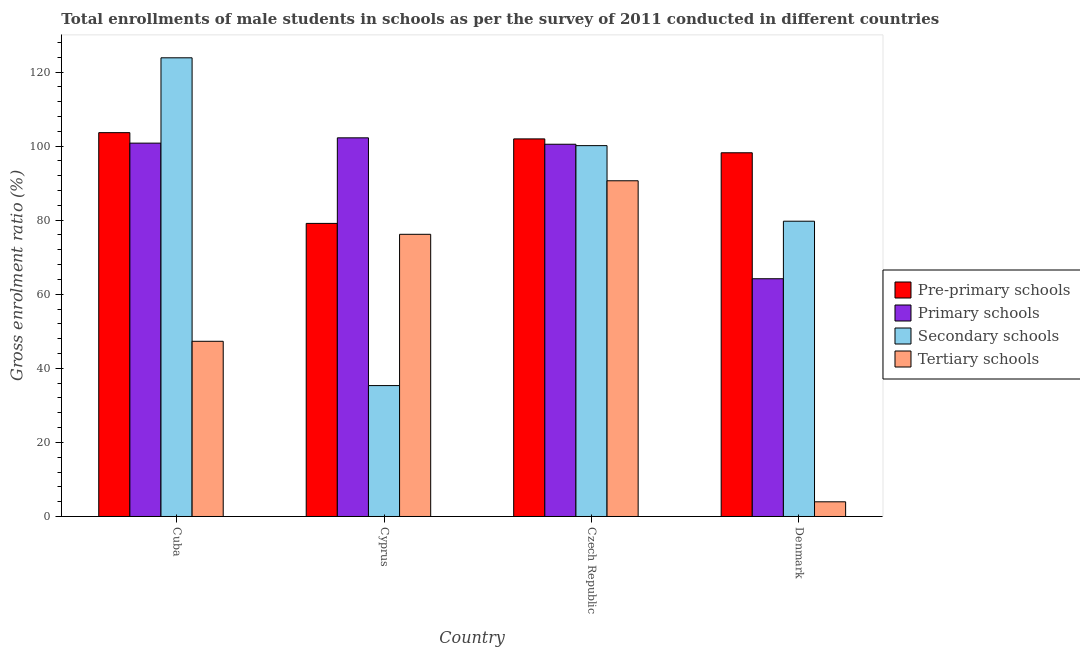How many different coloured bars are there?
Your answer should be very brief. 4. What is the label of the 2nd group of bars from the left?
Offer a very short reply. Cyprus. What is the gross enrolment ratio(male) in tertiary schools in Cuba?
Offer a terse response. 47.3. Across all countries, what is the maximum gross enrolment ratio(male) in pre-primary schools?
Keep it short and to the point. 103.63. Across all countries, what is the minimum gross enrolment ratio(male) in primary schools?
Ensure brevity in your answer.  64.19. In which country was the gross enrolment ratio(male) in primary schools maximum?
Give a very brief answer. Cyprus. In which country was the gross enrolment ratio(male) in primary schools minimum?
Keep it short and to the point. Denmark. What is the total gross enrolment ratio(male) in primary schools in the graph?
Offer a very short reply. 367.71. What is the difference between the gross enrolment ratio(male) in secondary schools in Cuba and that in Czech Republic?
Provide a succinct answer. 23.71. What is the difference between the gross enrolment ratio(male) in primary schools in Denmark and the gross enrolment ratio(male) in pre-primary schools in Czech Republic?
Your answer should be compact. -37.76. What is the average gross enrolment ratio(male) in primary schools per country?
Your answer should be compact. 91.93. What is the difference between the gross enrolment ratio(male) in pre-primary schools and gross enrolment ratio(male) in secondary schools in Cyprus?
Give a very brief answer. 43.78. In how many countries, is the gross enrolment ratio(male) in secondary schools greater than 100 %?
Your answer should be compact. 2. What is the ratio of the gross enrolment ratio(male) in pre-primary schools in Cyprus to that in Czech Republic?
Your response must be concise. 0.78. Is the gross enrolment ratio(male) in pre-primary schools in Cuba less than that in Cyprus?
Make the answer very short. No. Is the difference between the gross enrolment ratio(male) in primary schools in Cyprus and Denmark greater than the difference between the gross enrolment ratio(male) in secondary schools in Cyprus and Denmark?
Ensure brevity in your answer.  Yes. What is the difference between the highest and the second highest gross enrolment ratio(male) in pre-primary schools?
Offer a terse response. 1.69. What is the difference between the highest and the lowest gross enrolment ratio(male) in pre-primary schools?
Offer a terse response. 24.5. In how many countries, is the gross enrolment ratio(male) in pre-primary schools greater than the average gross enrolment ratio(male) in pre-primary schools taken over all countries?
Offer a very short reply. 3. Is it the case that in every country, the sum of the gross enrolment ratio(male) in pre-primary schools and gross enrolment ratio(male) in tertiary schools is greater than the sum of gross enrolment ratio(male) in secondary schools and gross enrolment ratio(male) in primary schools?
Your answer should be very brief. No. What does the 2nd bar from the left in Denmark represents?
Offer a very short reply. Primary schools. What does the 2nd bar from the right in Denmark represents?
Make the answer very short. Secondary schools. How many bars are there?
Your answer should be very brief. 16. Are all the bars in the graph horizontal?
Your answer should be very brief. No. How many countries are there in the graph?
Provide a short and direct response. 4. Does the graph contain any zero values?
Your answer should be very brief. No. How are the legend labels stacked?
Your answer should be very brief. Vertical. What is the title of the graph?
Give a very brief answer. Total enrollments of male students in schools as per the survey of 2011 conducted in different countries. Does "PFC gas" appear as one of the legend labels in the graph?
Offer a terse response. No. What is the label or title of the X-axis?
Provide a short and direct response. Country. What is the label or title of the Y-axis?
Keep it short and to the point. Gross enrolment ratio (%). What is the Gross enrolment ratio (%) in Pre-primary schools in Cuba?
Your answer should be very brief. 103.63. What is the Gross enrolment ratio (%) in Primary schools in Cuba?
Your answer should be very brief. 100.79. What is the Gross enrolment ratio (%) in Secondary schools in Cuba?
Ensure brevity in your answer.  123.83. What is the Gross enrolment ratio (%) of Tertiary schools in Cuba?
Offer a very short reply. 47.3. What is the Gross enrolment ratio (%) of Pre-primary schools in Cyprus?
Offer a very short reply. 79.13. What is the Gross enrolment ratio (%) in Primary schools in Cyprus?
Offer a very short reply. 102.23. What is the Gross enrolment ratio (%) in Secondary schools in Cyprus?
Make the answer very short. 35.34. What is the Gross enrolment ratio (%) in Tertiary schools in Cyprus?
Give a very brief answer. 76.18. What is the Gross enrolment ratio (%) in Pre-primary schools in Czech Republic?
Make the answer very short. 101.94. What is the Gross enrolment ratio (%) in Primary schools in Czech Republic?
Your answer should be very brief. 100.5. What is the Gross enrolment ratio (%) of Secondary schools in Czech Republic?
Your answer should be compact. 100.12. What is the Gross enrolment ratio (%) of Tertiary schools in Czech Republic?
Provide a short and direct response. 90.63. What is the Gross enrolment ratio (%) of Pre-primary schools in Denmark?
Keep it short and to the point. 98.19. What is the Gross enrolment ratio (%) of Primary schools in Denmark?
Your answer should be compact. 64.19. What is the Gross enrolment ratio (%) in Secondary schools in Denmark?
Give a very brief answer. 79.72. What is the Gross enrolment ratio (%) of Tertiary schools in Denmark?
Keep it short and to the point. 3.96. Across all countries, what is the maximum Gross enrolment ratio (%) in Pre-primary schools?
Your answer should be very brief. 103.63. Across all countries, what is the maximum Gross enrolment ratio (%) in Primary schools?
Offer a terse response. 102.23. Across all countries, what is the maximum Gross enrolment ratio (%) in Secondary schools?
Your response must be concise. 123.83. Across all countries, what is the maximum Gross enrolment ratio (%) of Tertiary schools?
Offer a very short reply. 90.63. Across all countries, what is the minimum Gross enrolment ratio (%) in Pre-primary schools?
Keep it short and to the point. 79.13. Across all countries, what is the minimum Gross enrolment ratio (%) in Primary schools?
Provide a short and direct response. 64.19. Across all countries, what is the minimum Gross enrolment ratio (%) in Secondary schools?
Ensure brevity in your answer.  35.34. Across all countries, what is the minimum Gross enrolment ratio (%) in Tertiary schools?
Ensure brevity in your answer.  3.96. What is the total Gross enrolment ratio (%) of Pre-primary schools in the graph?
Offer a very short reply. 382.89. What is the total Gross enrolment ratio (%) of Primary schools in the graph?
Make the answer very short. 367.71. What is the total Gross enrolment ratio (%) of Secondary schools in the graph?
Keep it short and to the point. 339.01. What is the total Gross enrolment ratio (%) of Tertiary schools in the graph?
Provide a short and direct response. 218.08. What is the difference between the Gross enrolment ratio (%) in Pre-primary schools in Cuba and that in Cyprus?
Make the answer very short. 24.5. What is the difference between the Gross enrolment ratio (%) of Primary schools in Cuba and that in Cyprus?
Make the answer very short. -1.43. What is the difference between the Gross enrolment ratio (%) in Secondary schools in Cuba and that in Cyprus?
Offer a terse response. 88.49. What is the difference between the Gross enrolment ratio (%) of Tertiary schools in Cuba and that in Cyprus?
Provide a succinct answer. -28.88. What is the difference between the Gross enrolment ratio (%) of Pre-primary schools in Cuba and that in Czech Republic?
Your answer should be very brief. 1.69. What is the difference between the Gross enrolment ratio (%) of Primary schools in Cuba and that in Czech Republic?
Provide a succinct answer. 0.3. What is the difference between the Gross enrolment ratio (%) of Secondary schools in Cuba and that in Czech Republic?
Give a very brief answer. 23.71. What is the difference between the Gross enrolment ratio (%) in Tertiary schools in Cuba and that in Czech Republic?
Your response must be concise. -43.33. What is the difference between the Gross enrolment ratio (%) of Pre-primary schools in Cuba and that in Denmark?
Ensure brevity in your answer.  5.43. What is the difference between the Gross enrolment ratio (%) of Primary schools in Cuba and that in Denmark?
Provide a succinct answer. 36.61. What is the difference between the Gross enrolment ratio (%) of Secondary schools in Cuba and that in Denmark?
Offer a very short reply. 44.12. What is the difference between the Gross enrolment ratio (%) in Tertiary schools in Cuba and that in Denmark?
Offer a very short reply. 43.34. What is the difference between the Gross enrolment ratio (%) in Pre-primary schools in Cyprus and that in Czech Republic?
Offer a very short reply. -22.82. What is the difference between the Gross enrolment ratio (%) of Primary schools in Cyprus and that in Czech Republic?
Your answer should be compact. 1.73. What is the difference between the Gross enrolment ratio (%) of Secondary schools in Cyprus and that in Czech Republic?
Ensure brevity in your answer.  -64.78. What is the difference between the Gross enrolment ratio (%) of Tertiary schools in Cyprus and that in Czech Republic?
Offer a terse response. -14.45. What is the difference between the Gross enrolment ratio (%) in Pre-primary schools in Cyprus and that in Denmark?
Offer a very short reply. -19.07. What is the difference between the Gross enrolment ratio (%) in Primary schools in Cyprus and that in Denmark?
Make the answer very short. 38.04. What is the difference between the Gross enrolment ratio (%) in Secondary schools in Cyprus and that in Denmark?
Make the answer very short. -44.38. What is the difference between the Gross enrolment ratio (%) of Tertiary schools in Cyprus and that in Denmark?
Provide a succinct answer. 72.22. What is the difference between the Gross enrolment ratio (%) in Pre-primary schools in Czech Republic and that in Denmark?
Keep it short and to the point. 3.75. What is the difference between the Gross enrolment ratio (%) in Primary schools in Czech Republic and that in Denmark?
Your answer should be compact. 36.31. What is the difference between the Gross enrolment ratio (%) in Secondary schools in Czech Republic and that in Denmark?
Your response must be concise. 20.41. What is the difference between the Gross enrolment ratio (%) of Tertiary schools in Czech Republic and that in Denmark?
Ensure brevity in your answer.  86.67. What is the difference between the Gross enrolment ratio (%) of Pre-primary schools in Cuba and the Gross enrolment ratio (%) of Primary schools in Cyprus?
Offer a terse response. 1.4. What is the difference between the Gross enrolment ratio (%) in Pre-primary schools in Cuba and the Gross enrolment ratio (%) in Secondary schools in Cyprus?
Provide a short and direct response. 68.29. What is the difference between the Gross enrolment ratio (%) in Pre-primary schools in Cuba and the Gross enrolment ratio (%) in Tertiary schools in Cyprus?
Your response must be concise. 27.45. What is the difference between the Gross enrolment ratio (%) in Primary schools in Cuba and the Gross enrolment ratio (%) in Secondary schools in Cyprus?
Your answer should be compact. 65.45. What is the difference between the Gross enrolment ratio (%) of Primary schools in Cuba and the Gross enrolment ratio (%) of Tertiary schools in Cyprus?
Offer a very short reply. 24.61. What is the difference between the Gross enrolment ratio (%) of Secondary schools in Cuba and the Gross enrolment ratio (%) of Tertiary schools in Cyprus?
Make the answer very short. 47.65. What is the difference between the Gross enrolment ratio (%) in Pre-primary schools in Cuba and the Gross enrolment ratio (%) in Primary schools in Czech Republic?
Offer a terse response. 3.13. What is the difference between the Gross enrolment ratio (%) of Pre-primary schools in Cuba and the Gross enrolment ratio (%) of Secondary schools in Czech Republic?
Your response must be concise. 3.51. What is the difference between the Gross enrolment ratio (%) in Pre-primary schools in Cuba and the Gross enrolment ratio (%) in Tertiary schools in Czech Republic?
Make the answer very short. 12.99. What is the difference between the Gross enrolment ratio (%) in Primary schools in Cuba and the Gross enrolment ratio (%) in Secondary schools in Czech Republic?
Your answer should be compact. 0.67. What is the difference between the Gross enrolment ratio (%) in Primary schools in Cuba and the Gross enrolment ratio (%) in Tertiary schools in Czech Republic?
Give a very brief answer. 10.16. What is the difference between the Gross enrolment ratio (%) of Secondary schools in Cuba and the Gross enrolment ratio (%) of Tertiary schools in Czech Republic?
Your answer should be compact. 33.2. What is the difference between the Gross enrolment ratio (%) in Pre-primary schools in Cuba and the Gross enrolment ratio (%) in Primary schools in Denmark?
Your response must be concise. 39.44. What is the difference between the Gross enrolment ratio (%) of Pre-primary schools in Cuba and the Gross enrolment ratio (%) of Secondary schools in Denmark?
Provide a succinct answer. 23.91. What is the difference between the Gross enrolment ratio (%) of Pre-primary schools in Cuba and the Gross enrolment ratio (%) of Tertiary schools in Denmark?
Your answer should be very brief. 99.67. What is the difference between the Gross enrolment ratio (%) of Primary schools in Cuba and the Gross enrolment ratio (%) of Secondary schools in Denmark?
Make the answer very short. 21.08. What is the difference between the Gross enrolment ratio (%) in Primary schools in Cuba and the Gross enrolment ratio (%) in Tertiary schools in Denmark?
Your answer should be compact. 96.83. What is the difference between the Gross enrolment ratio (%) in Secondary schools in Cuba and the Gross enrolment ratio (%) in Tertiary schools in Denmark?
Offer a terse response. 119.87. What is the difference between the Gross enrolment ratio (%) in Pre-primary schools in Cyprus and the Gross enrolment ratio (%) in Primary schools in Czech Republic?
Your response must be concise. -21.37. What is the difference between the Gross enrolment ratio (%) in Pre-primary schools in Cyprus and the Gross enrolment ratio (%) in Secondary schools in Czech Republic?
Provide a short and direct response. -21. What is the difference between the Gross enrolment ratio (%) in Pre-primary schools in Cyprus and the Gross enrolment ratio (%) in Tertiary schools in Czech Republic?
Your response must be concise. -11.51. What is the difference between the Gross enrolment ratio (%) in Primary schools in Cyprus and the Gross enrolment ratio (%) in Secondary schools in Czech Republic?
Your response must be concise. 2.11. What is the difference between the Gross enrolment ratio (%) of Primary schools in Cyprus and the Gross enrolment ratio (%) of Tertiary schools in Czech Republic?
Give a very brief answer. 11.59. What is the difference between the Gross enrolment ratio (%) of Secondary schools in Cyprus and the Gross enrolment ratio (%) of Tertiary schools in Czech Republic?
Ensure brevity in your answer.  -55.29. What is the difference between the Gross enrolment ratio (%) in Pre-primary schools in Cyprus and the Gross enrolment ratio (%) in Primary schools in Denmark?
Keep it short and to the point. 14.94. What is the difference between the Gross enrolment ratio (%) of Pre-primary schools in Cyprus and the Gross enrolment ratio (%) of Secondary schools in Denmark?
Offer a terse response. -0.59. What is the difference between the Gross enrolment ratio (%) in Pre-primary schools in Cyprus and the Gross enrolment ratio (%) in Tertiary schools in Denmark?
Offer a terse response. 75.16. What is the difference between the Gross enrolment ratio (%) in Primary schools in Cyprus and the Gross enrolment ratio (%) in Secondary schools in Denmark?
Provide a succinct answer. 22.51. What is the difference between the Gross enrolment ratio (%) of Primary schools in Cyprus and the Gross enrolment ratio (%) of Tertiary schools in Denmark?
Provide a succinct answer. 98.27. What is the difference between the Gross enrolment ratio (%) of Secondary schools in Cyprus and the Gross enrolment ratio (%) of Tertiary schools in Denmark?
Your answer should be compact. 31.38. What is the difference between the Gross enrolment ratio (%) in Pre-primary schools in Czech Republic and the Gross enrolment ratio (%) in Primary schools in Denmark?
Offer a very short reply. 37.76. What is the difference between the Gross enrolment ratio (%) in Pre-primary schools in Czech Republic and the Gross enrolment ratio (%) in Secondary schools in Denmark?
Offer a very short reply. 22.23. What is the difference between the Gross enrolment ratio (%) of Pre-primary schools in Czech Republic and the Gross enrolment ratio (%) of Tertiary schools in Denmark?
Keep it short and to the point. 97.98. What is the difference between the Gross enrolment ratio (%) of Primary schools in Czech Republic and the Gross enrolment ratio (%) of Secondary schools in Denmark?
Keep it short and to the point. 20.78. What is the difference between the Gross enrolment ratio (%) of Primary schools in Czech Republic and the Gross enrolment ratio (%) of Tertiary schools in Denmark?
Offer a very short reply. 96.53. What is the difference between the Gross enrolment ratio (%) of Secondary schools in Czech Republic and the Gross enrolment ratio (%) of Tertiary schools in Denmark?
Provide a succinct answer. 96.16. What is the average Gross enrolment ratio (%) in Pre-primary schools per country?
Provide a short and direct response. 95.72. What is the average Gross enrolment ratio (%) in Primary schools per country?
Give a very brief answer. 91.93. What is the average Gross enrolment ratio (%) in Secondary schools per country?
Your response must be concise. 84.75. What is the average Gross enrolment ratio (%) of Tertiary schools per country?
Offer a terse response. 54.52. What is the difference between the Gross enrolment ratio (%) in Pre-primary schools and Gross enrolment ratio (%) in Primary schools in Cuba?
Keep it short and to the point. 2.83. What is the difference between the Gross enrolment ratio (%) in Pre-primary schools and Gross enrolment ratio (%) in Secondary schools in Cuba?
Keep it short and to the point. -20.2. What is the difference between the Gross enrolment ratio (%) of Pre-primary schools and Gross enrolment ratio (%) of Tertiary schools in Cuba?
Provide a succinct answer. 56.33. What is the difference between the Gross enrolment ratio (%) in Primary schools and Gross enrolment ratio (%) in Secondary schools in Cuba?
Your answer should be compact. -23.04. What is the difference between the Gross enrolment ratio (%) of Primary schools and Gross enrolment ratio (%) of Tertiary schools in Cuba?
Give a very brief answer. 53.5. What is the difference between the Gross enrolment ratio (%) of Secondary schools and Gross enrolment ratio (%) of Tertiary schools in Cuba?
Provide a short and direct response. 76.53. What is the difference between the Gross enrolment ratio (%) in Pre-primary schools and Gross enrolment ratio (%) in Primary schools in Cyprus?
Your answer should be compact. -23.1. What is the difference between the Gross enrolment ratio (%) of Pre-primary schools and Gross enrolment ratio (%) of Secondary schools in Cyprus?
Provide a short and direct response. 43.78. What is the difference between the Gross enrolment ratio (%) of Pre-primary schools and Gross enrolment ratio (%) of Tertiary schools in Cyprus?
Ensure brevity in your answer.  2.94. What is the difference between the Gross enrolment ratio (%) of Primary schools and Gross enrolment ratio (%) of Secondary schools in Cyprus?
Keep it short and to the point. 66.89. What is the difference between the Gross enrolment ratio (%) of Primary schools and Gross enrolment ratio (%) of Tertiary schools in Cyprus?
Keep it short and to the point. 26.05. What is the difference between the Gross enrolment ratio (%) of Secondary schools and Gross enrolment ratio (%) of Tertiary schools in Cyprus?
Provide a short and direct response. -40.84. What is the difference between the Gross enrolment ratio (%) of Pre-primary schools and Gross enrolment ratio (%) of Primary schools in Czech Republic?
Your answer should be very brief. 1.44. What is the difference between the Gross enrolment ratio (%) in Pre-primary schools and Gross enrolment ratio (%) in Secondary schools in Czech Republic?
Your response must be concise. 1.82. What is the difference between the Gross enrolment ratio (%) in Pre-primary schools and Gross enrolment ratio (%) in Tertiary schools in Czech Republic?
Give a very brief answer. 11.31. What is the difference between the Gross enrolment ratio (%) of Primary schools and Gross enrolment ratio (%) of Secondary schools in Czech Republic?
Offer a very short reply. 0.38. What is the difference between the Gross enrolment ratio (%) in Primary schools and Gross enrolment ratio (%) in Tertiary schools in Czech Republic?
Keep it short and to the point. 9.86. What is the difference between the Gross enrolment ratio (%) of Secondary schools and Gross enrolment ratio (%) of Tertiary schools in Czech Republic?
Give a very brief answer. 9.49. What is the difference between the Gross enrolment ratio (%) of Pre-primary schools and Gross enrolment ratio (%) of Primary schools in Denmark?
Ensure brevity in your answer.  34.01. What is the difference between the Gross enrolment ratio (%) in Pre-primary schools and Gross enrolment ratio (%) in Secondary schools in Denmark?
Your answer should be compact. 18.48. What is the difference between the Gross enrolment ratio (%) of Pre-primary schools and Gross enrolment ratio (%) of Tertiary schools in Denmark?
Offer a terse response. 94.23. What is the difference between the Gross enrolment ratio (%) of Primary schools and Gross enrolment ratio (%) of Secondary schools in Denmark?
Offer a terse response. -15.53. What is the difference between the Gross enrolment ratio (%) in Primary schools and Gross enrolment ratio (%) in Tertiary schools in Denmark?
Offer a very short reply. 60.22. What is the difference between the Gross enrolment ratio (%) of Secondary schools and Gross enrolment ratio (%) of Tertiary schools in Denmark?
Provide a succinct answer. 75.75. What is the ratio of the Gross enrolment ratio (%) of Pre-primary schools in Cuba to that in Cyprus?
Your answer should be compact. 1.31. What is the ratio of the Gross enrolment ratio (%) of Primary schools in Cuba to that in Cyprus?
Provide a succinct answer. 0.99. What is the ratio of the Gross enrolment ratio (%) of Secondary schools in Cuba to that in Cyprus?
Offer a terse response. 3.5. What is the ratio of the Gross enrolment ratio (%) of Tertiary schools in Cuba to that in Cyprus?
Make the answer very short. 0.62. What is the ratio of the Gross enrolment ratio (%) of Pre-primary schools in Cuba to that in Czech Republic?
Provide a succinct answer. 1.02. What is the ratio of the Gross enrolment ratio (%) of Secondary schools in Cuba to that in Czech Republic?
Make the answer very short. 1.24. What is the ratio of the Gross enrolment ratio (%) in Tertiary schools in Cuba to that in Czech Republic?
Give a very brief answer. 0.52. What is the ratio of the Gross enrolment ratio (%) in Pre-primary schools in Cuba to that in Denmark?
Provide a succinct answer. 1.06. What is the ratio of the Gross enrolment ratio (%) in Primary schools in Cuba to that in Denmark?
Provide a short and direct response. 1.57. What is the ratio of the Gross enrolment ratio (%) in Secondary schools in Cuba to that in Denmark?
Keep it short and to the point. 1.55. What is the ratio of the Gross enrolment ratio (%) of Tertiary schools in Cuba to that in Denmark?
Your answer should be compact. 11.94. What is the ratio of the Gross enrolment ratio (%) of Pre-primary schools in Cyprus to that in Czech Republic?
Give a very brief answer. 0.78. What is the ratio of the Gross enrolment ratio (%) of Primary schools in Cyprus to that in Czech Republic?
Your answer should be very brief. 1.02. What is the ratio of the Gross enrolment ratio (%) in Secondary schools in Cyprus to that in Czech Republic?
Make the answer very short. 0.35. What is the ratio of the Gross enrolment ratio (%) of Tertiary schools in Cyprus to that in Czech Republic?
Give a very brief answer. 0.84. What is the ratio of the Gross enrolment ratio (%) in Pre-primary schools in Cyprus to that in Denmark?
Your answer should be very brief. 0.81. What is the ratio of the Gross enrolment ratio (%) of Primary schools in Cyprus to that in Denmark?
Make the answer very short. 1.59. What is the ratio of the Gross enrolment ratio (%) in Secondary schools in Cyprus to that in Denmark?
Offer a very short reply. 0.44. What is the ratio of the Gross enrolment ratio (%) of Tertiary schools in Cyprus to that in Denmark?
Give a very brief answer. 19.23. What is the ratio of the Gross enrolment ratio (%) in Pre-primary schools in Czech Republic to that in Denmark?
Keep it short and to the point. 1.04. What is the ratio of the Gross enrolment ratio (%) in Primary schools in Czech Republic to that in Denmark?
Provide a succinct answer. 1.57. What is the ratio of the Gross enrolment ratio (%) of Secondary schools in Czech Republic to that in Denmark?
Ensure brevity in your answer.  1.26. What is the ratio of the Gross enrolment ratio (%) of Tertiary schools in Czech Republic to that in Denmark?
Keep it short and to the point. 22.87. What is the difference between the highest and the second highest Gross enrolment ratio (%) of Pre-primary schools?
Provide a short and direct response. 1.69. What is the difference between the highest and the second highest Gross enrolment ratio (%) in Primary schools?
Provide a succinct answer. 1.43. What is the difference between the highest and the second highest Gross enrolment ratio (%) of Secondary schools?
Your response must be concise. 23.71. What is the difference between the highest and the second highest Gross enrolment ratio (%) of Tertiary schools?
Ensure brevity in your answer.  14.45. What is the difference between the highest and the lowest Gross enrolment ratio (%) in Pre-primary schools?
Provide a short and direct response. 24.5. What is the difference between the highest and the lowest Gross enrolment ratio (%) of Primary schools?
Provide a short and direct response. 38.04. What is the difference between the highest and the lowest Gross enrolment ratio (%) in Secondary schools?
Make the answer very short. 88.49. What is the difference between the highest and the lowest Gross enrolment ratio (%) in Tertiary schools?
Make the answer very short. 86.67. 